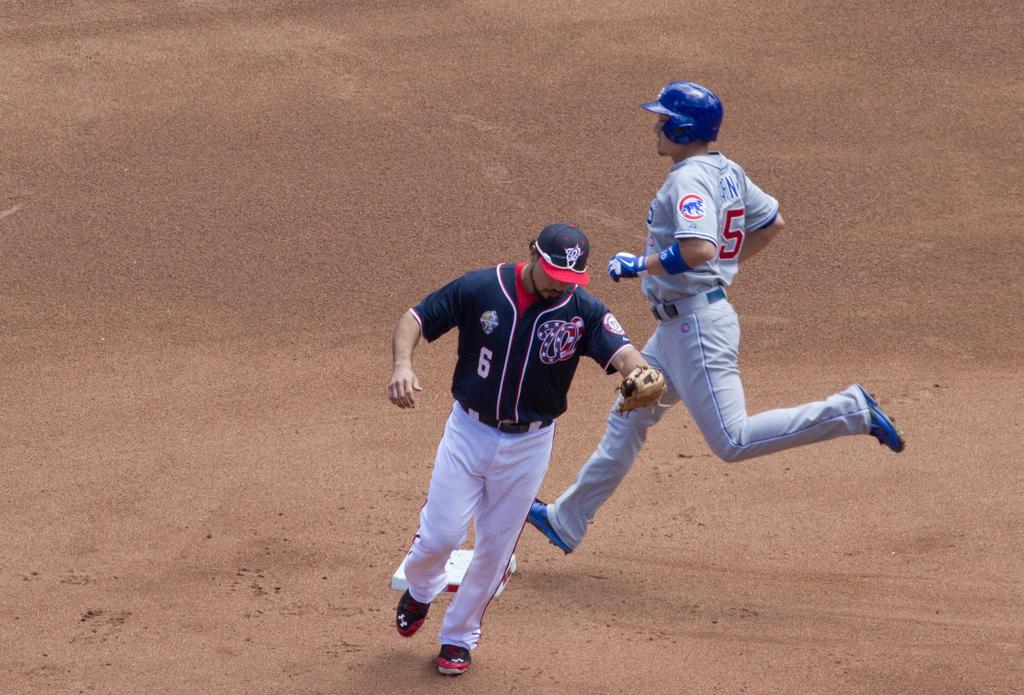Provide a one-sentence caption for the provided image. Baseball player wearing jersey number 5 running to base. 